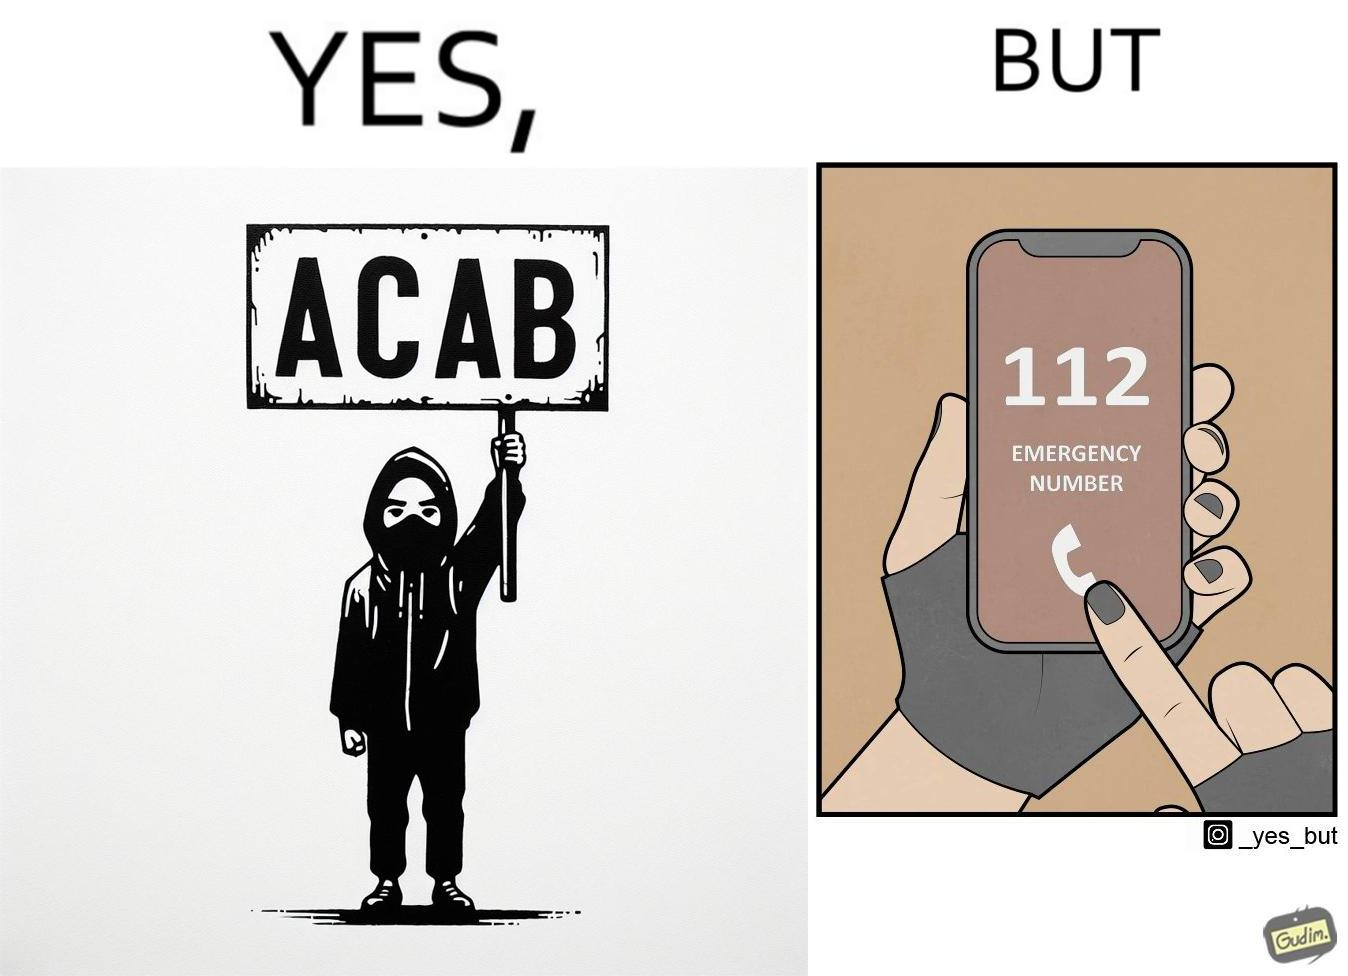Explain the humor or irony in this image. This is funny because on the one hand this person is rebelling against cops (slogan being All Cops Are Bad - ACAB), but on the other hand they are also calling the cops for help. 